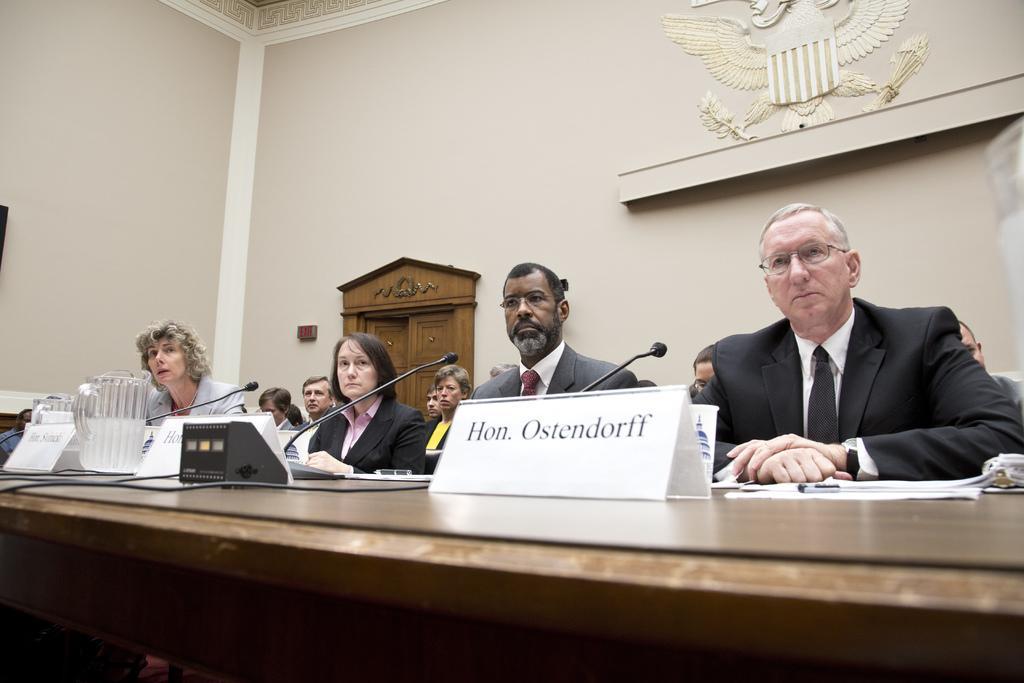Can you describe this image briefly? Few persons sitting. We can see table on the table we can see name broads,glass,microphones. On the background we can see wall. 